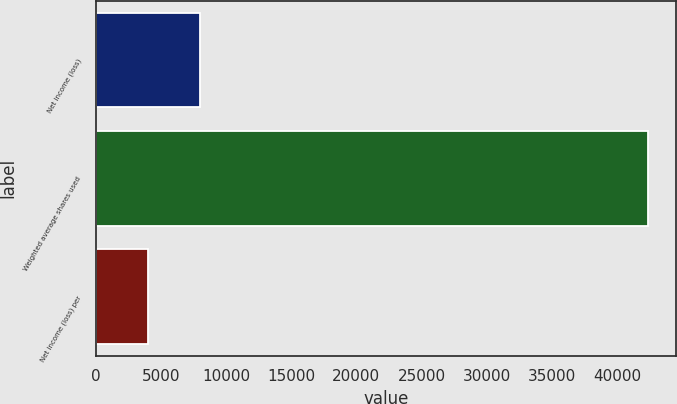Convert chart. <chart><loc_0><loc_0><loc_500><loc_500><bar_chart><fcel>Net income (loss)<fcel>Weighted average shares used<fcel>Net income (loss) per<nl><fcel>8034.44<fcel>42391.2<fcel>4017.24<nl></chart> 